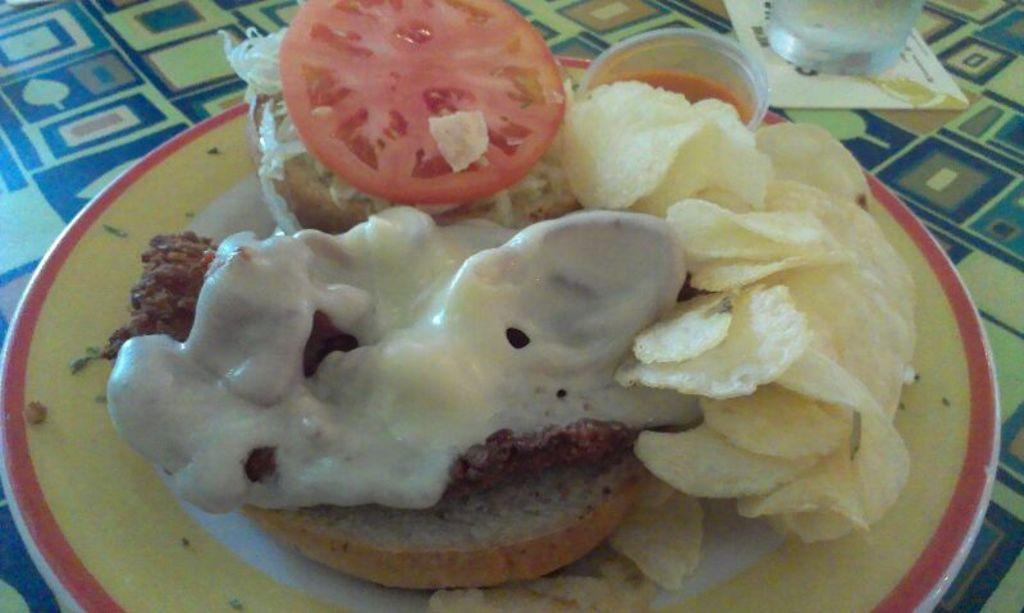What type of furniture is present in the image? There is a table in the image. What is placed on the table? There is a glass and a plate on the table. Can you describe the food item in the image? Unfortunately, the specific food item cannot be identified from the provided facts. How many planes are flying over the table in the image? There are no planes visible in the image; it only features a table, a glass, and a plate. 